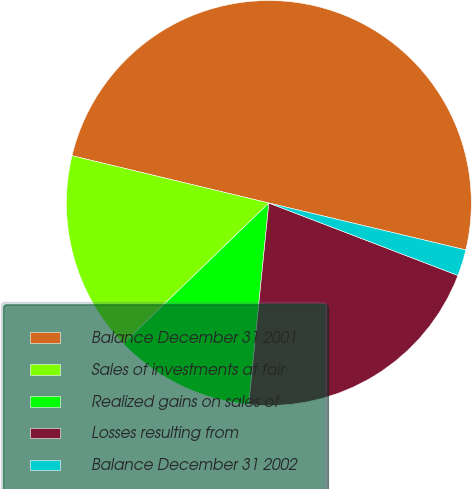Convert chart to OTSL. <chart><loc_0><loc_0><loc_500><loc_500><pie_chart><fcel>Balance December 31 2001<fcel>Sales of investments at fair<fcel>Realized gains on sales of<fcel>Losses resulting from<fcel>Balance December 31 2002<nl><fcel>49.97%<fcel>15.98%<fcel>11.19%<fcel>20.76%<fcel>2.1%<nl></chart> 